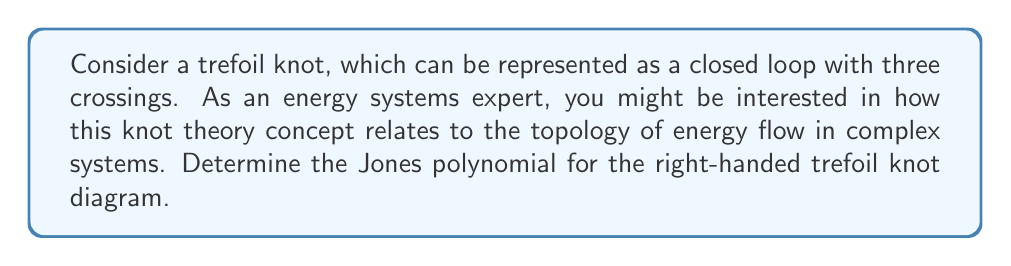Show me your answer to this math problem. To determine the Jones polynomial for the right-handed trefoil knot, we'll follow these steps:

1. Identify the knot: The right-handed trefoil knot has three positive crossings.

2. Apply the skein relation: The Jones polynomial $V(L)$ satisfies the skein relation:
   $$t^{-1}V(L_+) - tV(L_-) = (t^{1/2} - t^{-1/2})V(L_0)$$
   where $L_+$, $L_-$, and $L_0$ represent positive crossing, negative crossing, and smoothed crossing, respectively.

3. Start with the trefoil knot and apply the skein relation at one crossing:
   $$t^{-1}V(\text{trefoil}) - tV(\text{unknot}) = (t^{1/2} - t^{-1/2})V(\text{Hopf link})$$

4. Recall known values:
   - $V(\text{unknot}) = 1$
   - $V(\text{Hopf link}) = -t^{1/2} - t^{-3/2}$

5. Substitute these values:
   $$t^{-1}V(\text{trefoil}) - t = (t^{1/2} - t^{-1/2})(-t^{1/2} - t^{-3/2})$$

6. Simplify:
   $$t^{-1}V(\text{trefoil}) = -t^2 - 1 + t^{-2}$$

7. Solve for $V(\text{trefoil})$:
   $$V(\text{trefoil}) = -t^3 - t - t^{-1}$$

This polynomial represents the Jones polynomial for the right-handed trefoil knot.
Answer: $V(\text{trefoil}) = -t^3 - t - t^{-1}$ 